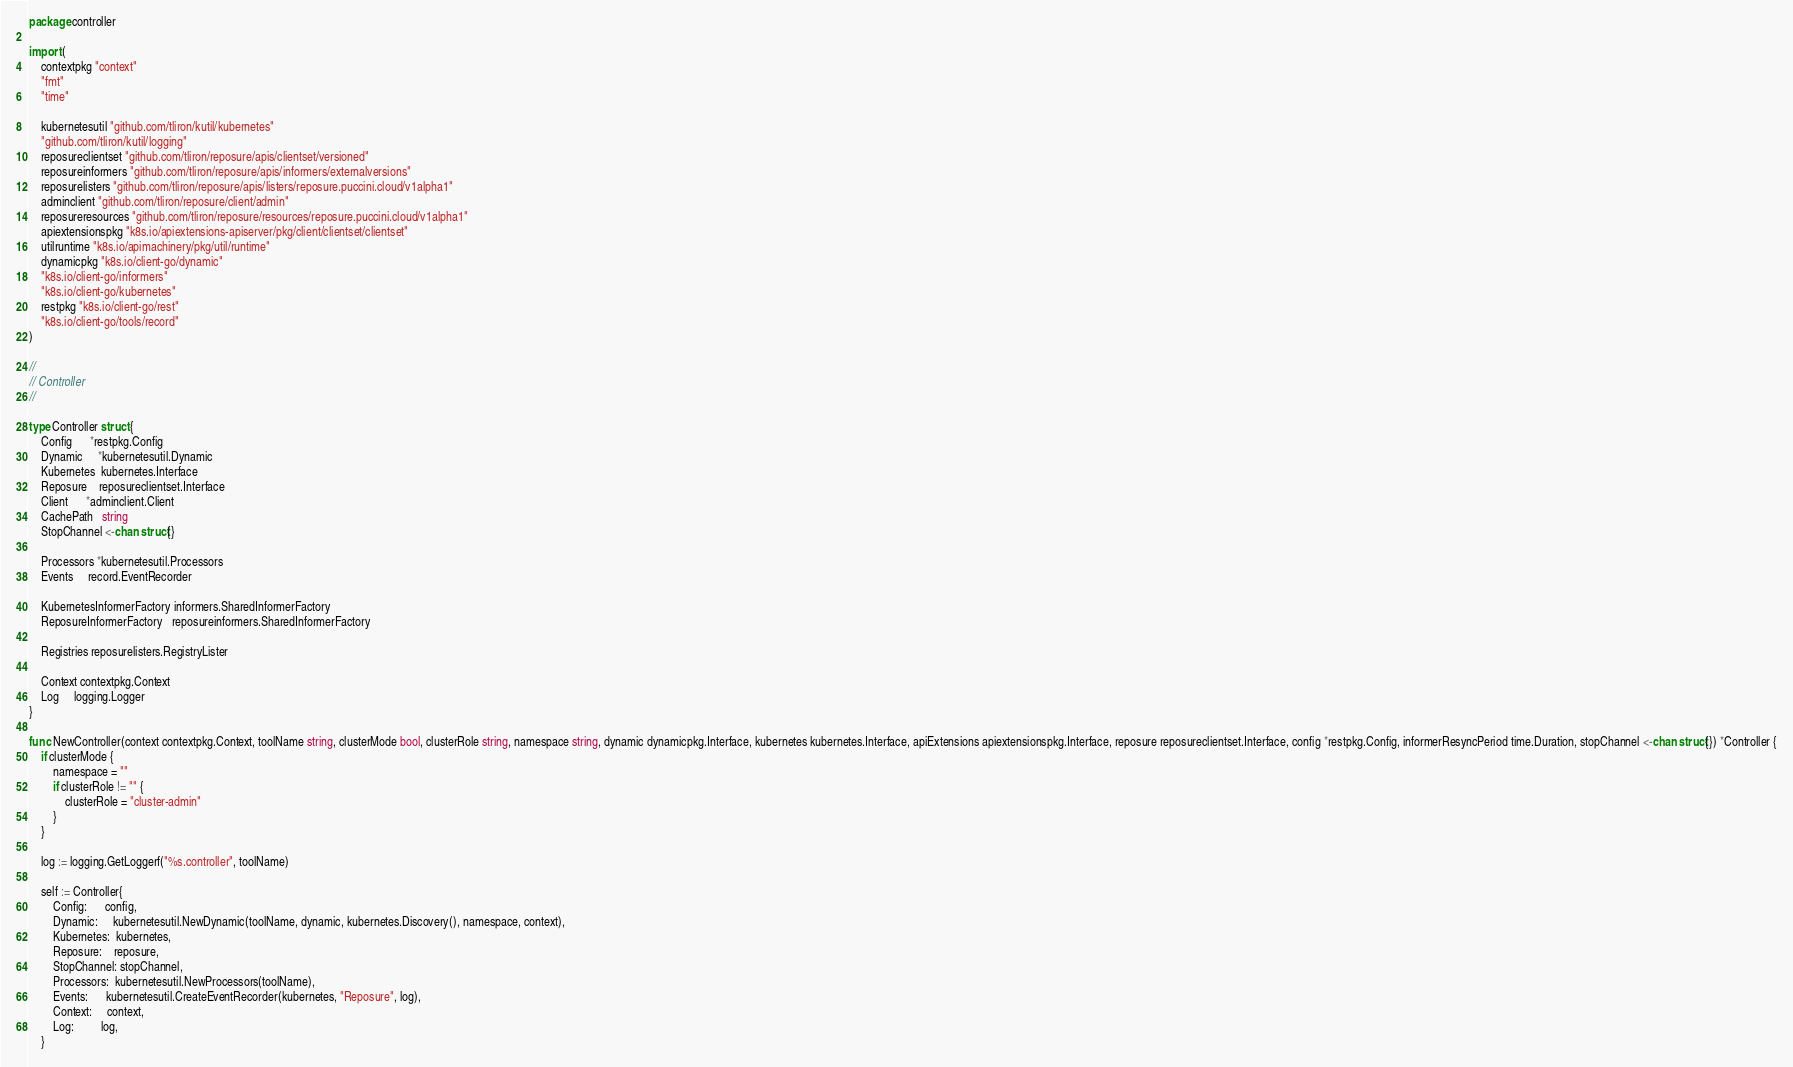Convert code to text. <code><loc_0><loc_0><loc_500><loc_500><_Go_>package controller

import (
	contextpkg "context"
	"fmt"
	"time"

	kubernetesutil "github.com/tliron/kutil/kubernetes"
	"github.com/tliron/kutil/logging"
	reposureclientset "github.com/tliron/reposure/apis/clientset/versioned"
	reposureinformers "github.com/tliron/reposure/apis/informers/externalversions"
	reposurelisters "github.com/tliron/reposure/apis/listers/reposure.puccini.cloud/v1alpha1"
	adminclient "github.com/tliron/reposure/client/admin"
	reposureresources "github.com/tliron/reposure/resources/reposure.puccini.cloud/v1alpha1"
	apiextensionspkg "k8s.io/apiextensions-apiserver/pkg/client/clientset/clientset"
	utilruntime "k8s.io/apimachinery/pkg/util/runtime"
	dynamicpkg "k8s.io/client-go/dynamic"
	"k8s.io/client-go/informers"
	"k8s.io/client-go/kubernetes"
	restpkg "k8s.io/client-go/rest"
	"k8s.io/client-go/tools/record"
)

//
// Controller
//

type Controller struct {
	Config      *restpkg.Config
	Dynamic     *kubernetesutil.Dynamic
	Kubernetes  kubernetes.Interface
	Reposure    reposureclientset.Interface
	Client      *adminclient.Client
	CachePath   string
	StopChannel <-chan struct{}

	Processors *kubernetesutil.Processors
	Events     record.EventRecorder

	KubernetesInformerFactory informers.SharedInformerFactory
	ReposureInformerFactory   reposureinformers.SharedInformerFactory

	Registries reposurelisters.RegistryLister

	Context contextpkg.Context
	Log     logging.Logger
}

func NewController(context contextpkg.Context, toolName string, clusterMode bool, clusterRole string, namespace string, dynamic dynamicpkg.Interface, kubernetes kubernetes.Interface, apiExtensions apiextensionspkg.Interface, reposure reposureclientset.Interface, config *restpkg.Config, informerResyncPeriod time.Duration, stopChannel <-chan struct{}) *Controller {
	if clusterMode {
		namespace = ""
		if clusterRole != "" {
			clusterRole = "cluster-admin"
		}
	}

	log := logging.GetLoggerf("%s.controller", toolName)

	self := Controller{
		Config:      config,
		Dynamic:     kubernetesutil.NewDynamic(toolName, dynamic, kubernetes.Discovery(), namespace, context),
		Kubernetes:  kubernetes,
		Reposure:    reposure,
		StopChannel: stopChannel,
		Processors:  kubernetesutil.NewProcessors(toolName),
		Events:      kubernetesutil.CreateEventRecorder(kubernetes, "Reposure", log),
		Context:     context,
		Log:         log,
	}
</code> 